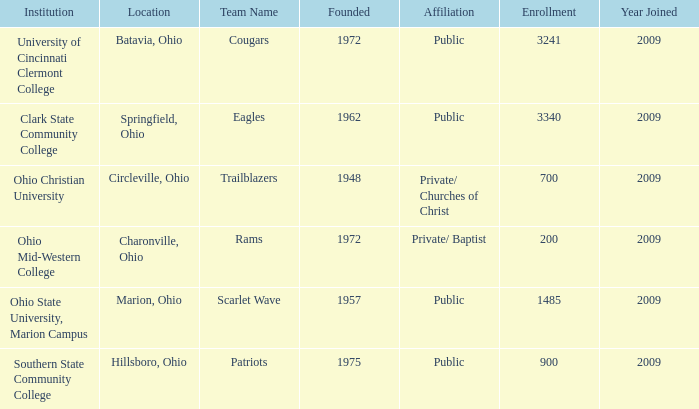What is the place for the team name of eagles? Springfield, Ohio. 